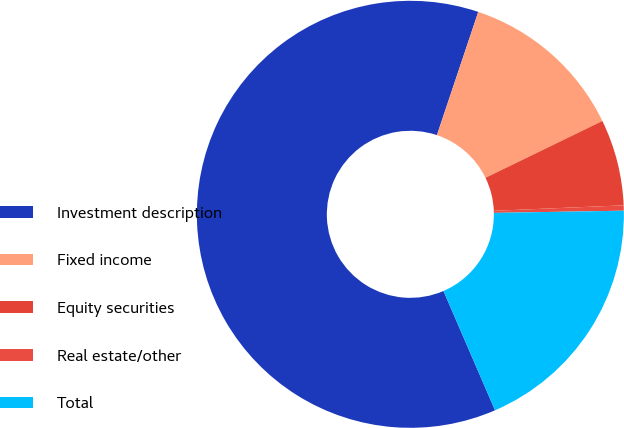Convert chart. <chart><loc_0><loc_0><loc_500><loc_500><pie_chart><fcel>Investment description<fcel>Fixed income<fcel>Equity securities<fcel>Real estate/other<fcel>Total<nl><fcel>61.65%<fcel>12.65%<fcel>6.53%<fcel>0.4%<fcel>18.78%<nl></chart> 